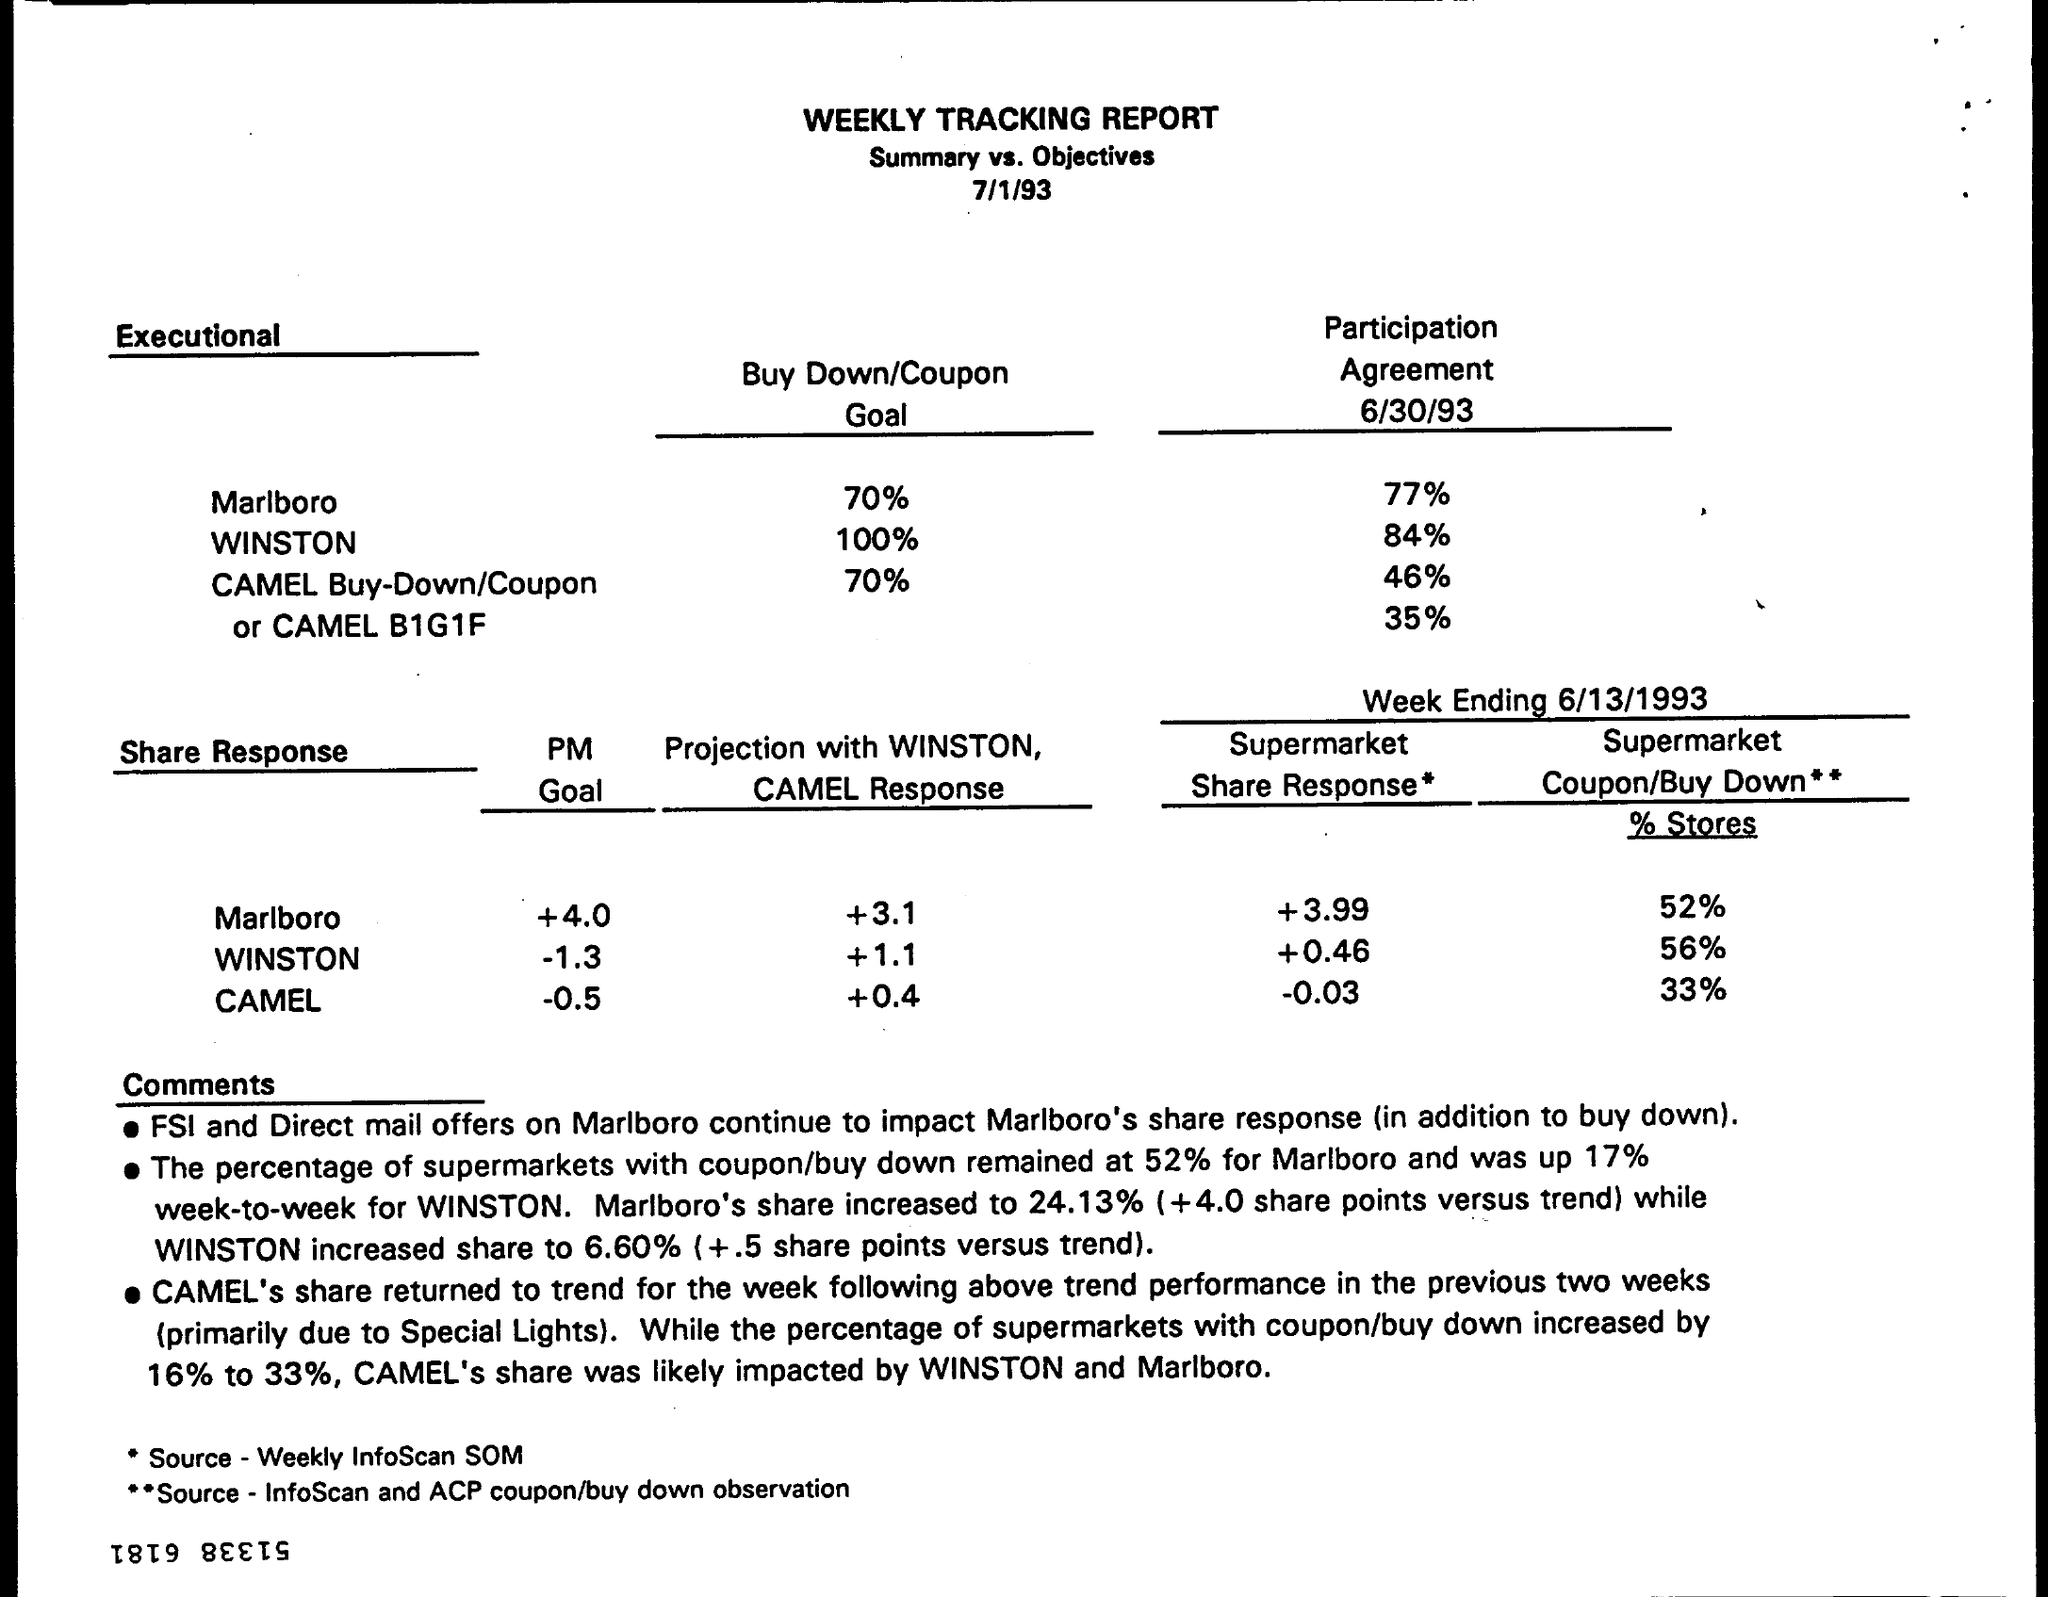What insights can be gained from the 'Participation Agreement' percentages mentioned in the report? The 'Participation Agreement' percentages indicate the level of participation by supermarkets in the promotional activities on the given date, 6/30/93. For instance, 77% of supermarkets participated in Marlboro's promotion, while WINSTON and CAMEL had lower participation rates of 84% and 46% respectively. A particularly low rate of 35% is noted for the CAMEL B1G1F promotion. These figures can provide insight into the market engagement and effectiveness of each brand's promotional strategy. 